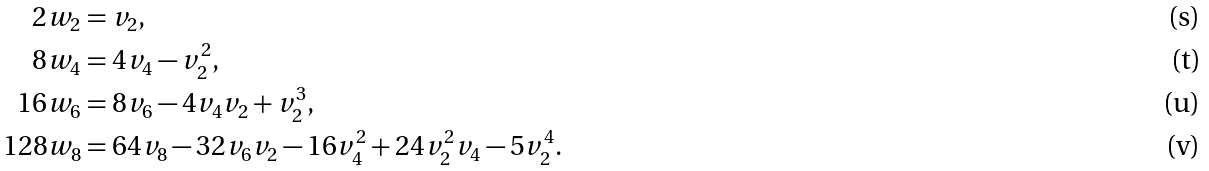Convert formula to latex. <formula><loc_0><loc_0><loc_500><loc_500>2 w _ { 2 } & = v _ { 2 } , \\ 8 w _ { 4 } & = 4 v _ { 4 } - v _ { 2 } ^ { 2 } , \\ 1 6 w _ { 6 } & = 8 v _ { 6 } - 4 v _ { 4 } v _ { 2 } + v _ { 2 } ^ { 3 } , \\ 1 2 8 w _ { 8 } & = 6 4 v _ { 8 } - 3 2 v _ { 6 } v _ { 2 } - 1 6 v _ { 4 } ^ { 2 } + 2 4 v _ { 2 } ^ { 2 } v _ { 4 } - 5 v _ { 2 } ^ { 4 } .</formula> 